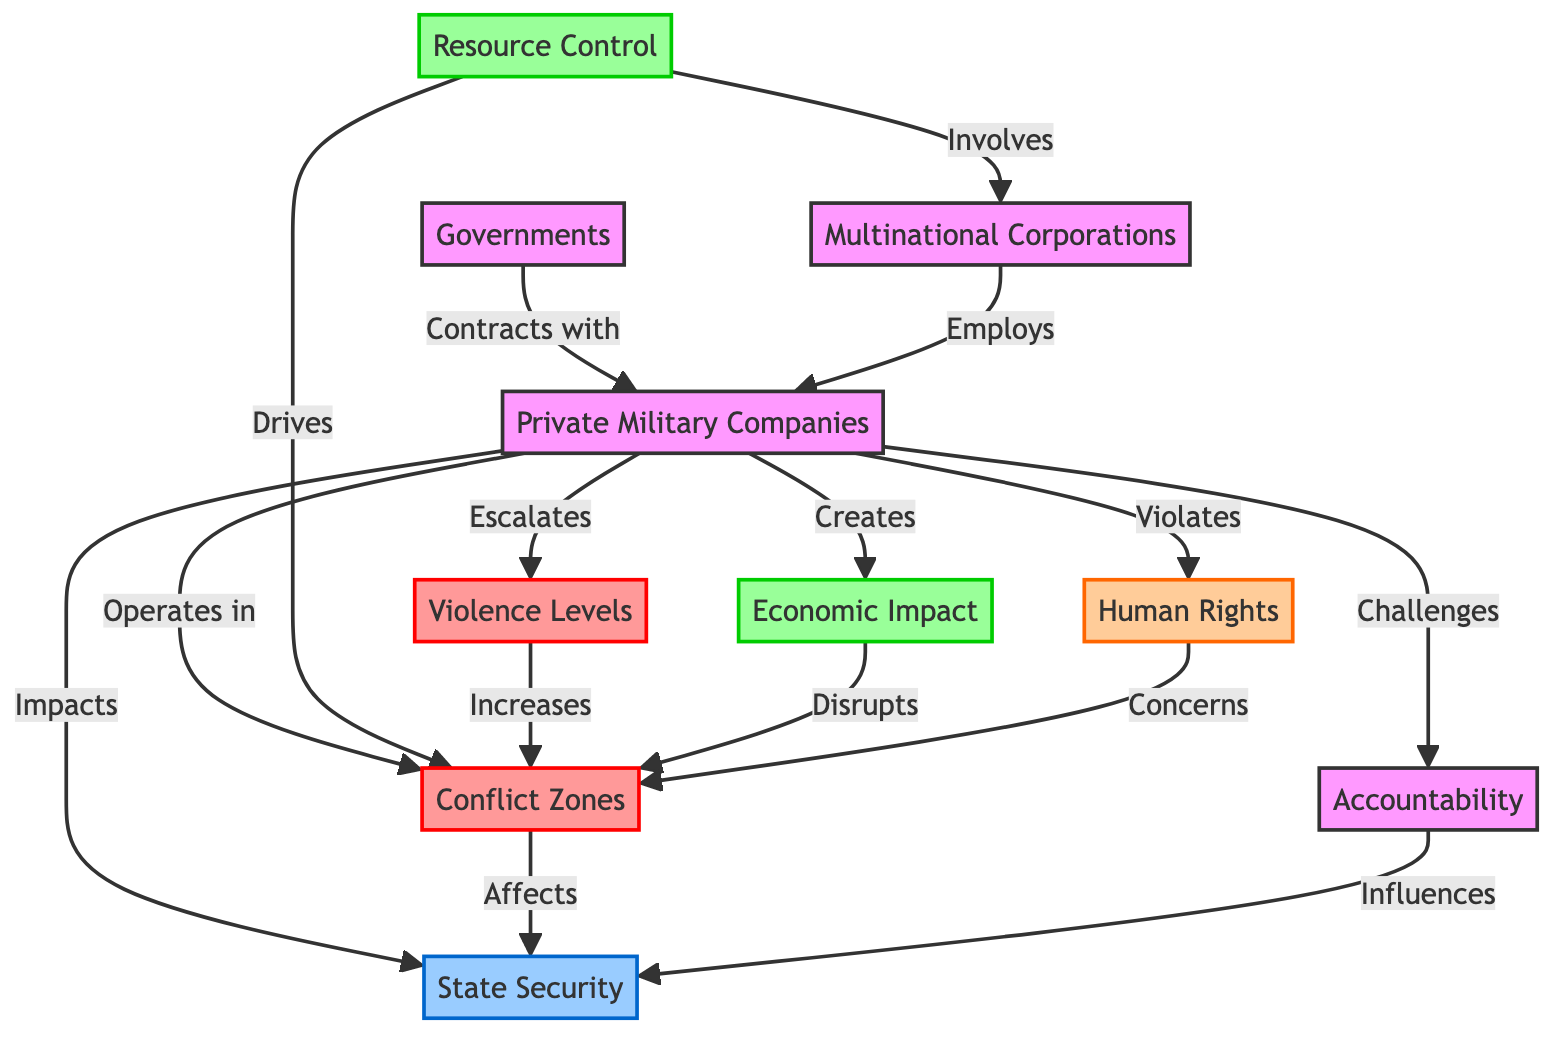What node represents the entities that operate in conflict zones? The node labeled "Private Military Companies (PMCs)" directly connects with the "Conflict Zones" node through the edge labeled "Operates in."
Answer: Private Military Companies (PMCs) How many nodes are in the diagram? By counting the listed nodes in the data, we find there are 10 distinct nodes.
Answer: 10 What relationship exists between Private Military Companies and State Security? The edge between "Private Military Companies (PMCs)" and "State Security" is labeled "Impacts," indicating a direct effect of PMCs on state security.
Answer: Impacts What influences State Security according to the diagram? The node "Accountability" has a directed edge to "State Security," labeled "Influences," indicating that accountability impacts state security.
Answer: Accountability What drives conflict zones according to the diagram? The edge from "Resource Control" to "Conflict Zones" is labeled "Drives," indicating that resource control is a driving factor for conflict zones.
Answer: Drives What is created by Private Military Companies? The edge labeled "Creates" between the “Private Military Companies (PMCs)” and "Economic Impact" suggests that PMCs have a role in creating economic impacts.
Answer: Economic Impact How does violence level affect conflict zones? The connection labeled "Increases" from "Violence Levels" to "Conflict Zones" indicates that higher violence levels will affect conflict zones.
Answer: Increases Which entities contract with Private Military Companies? The edge labeled "Contracts with" connects "Governments" to "Private Military Companies," indicating that governments enter contracts with PMCs.
Answer: Governments What are some concerns related to conflict zones? The node "Human Rights" connects to "Conflict Zones" and is labeled "Concerns," indicating that human rights issues are significant in conflict zones.
Answer: Human Rights How do Private Military Companies affect violence levels? The edge between "Private Military Companies" and "Violence Levels" is labeled "Escalates," which shows that PMCs are linked to the increase in violence levels in conflict zones.
Answer: Escalates 